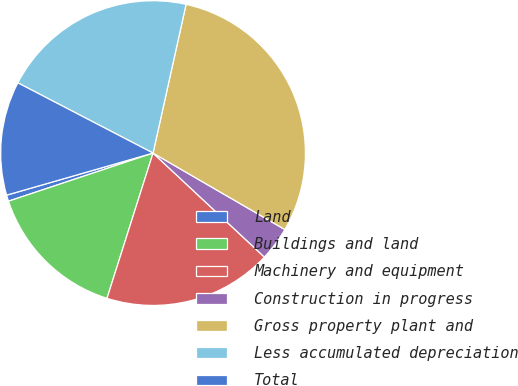<chart> <loc_0><loc_0><loc_500><loc_500><pie_chart><fcel>Land<fcel>Buildings and land<fcel>Machinery and equipment<fcel>Construction in progress<fcel>Gross property plant and<fcel>Less accumulated depreciation<fcel>Total<nl><fcel>0.66%<fcel>15.0%<fcel>17.93%<fcel>3.59%<fcel>29.89%<fcel>20.85%<fcel>12.08%<nl></chart> 